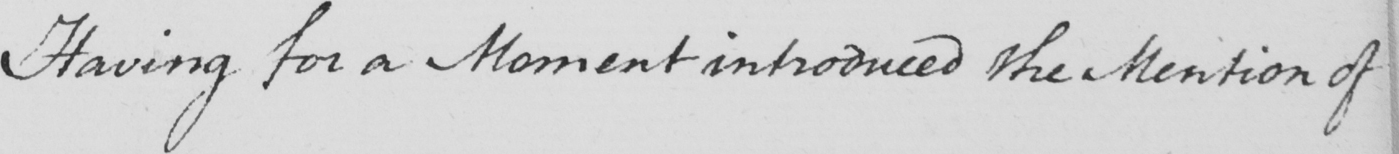What is written in this line of handwriting? Having for a Moment introduced the Mention of 